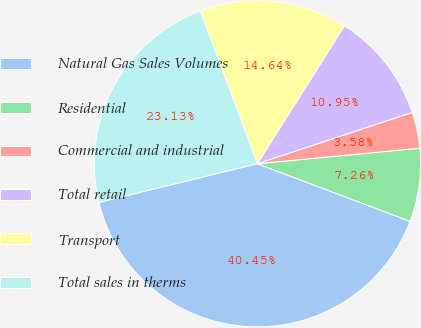Convert chart to OTSL. <chart><loc_0><loc_0><loc_500><loc_500><pie_chart><fcel>Natural Gas Sales Volumes<fcel>Residential<fcel>Commercial and industrial<fcel>Total retail<fcel>Transport<fcel>Total sales in therms<nl><fcel>40.45%<fcel>7.26%<fcel>3.58%<fcel>10.95%<fcel>14.64%<fcel>23.13%<nl></chart> 